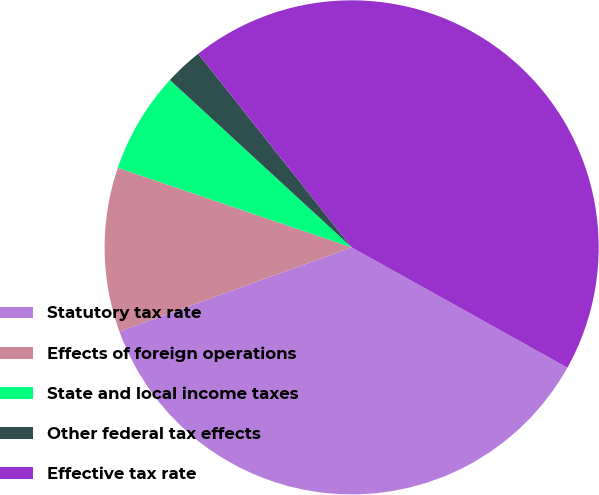Convert chart. <chart><loc_0><loc_0><loc_500><loc_500><pie_chart><fcel>Statutory tax rate<fcel>Effects of foreign operations<fcel>State and local income taxes<fcel>Other federal tax effects<fcel>Effective tax rate<nl><fcel>36.38%<fcel>10.75%<fcel>6.62%<fcel>2.49%<fcel>43.76%<nl></chart> 